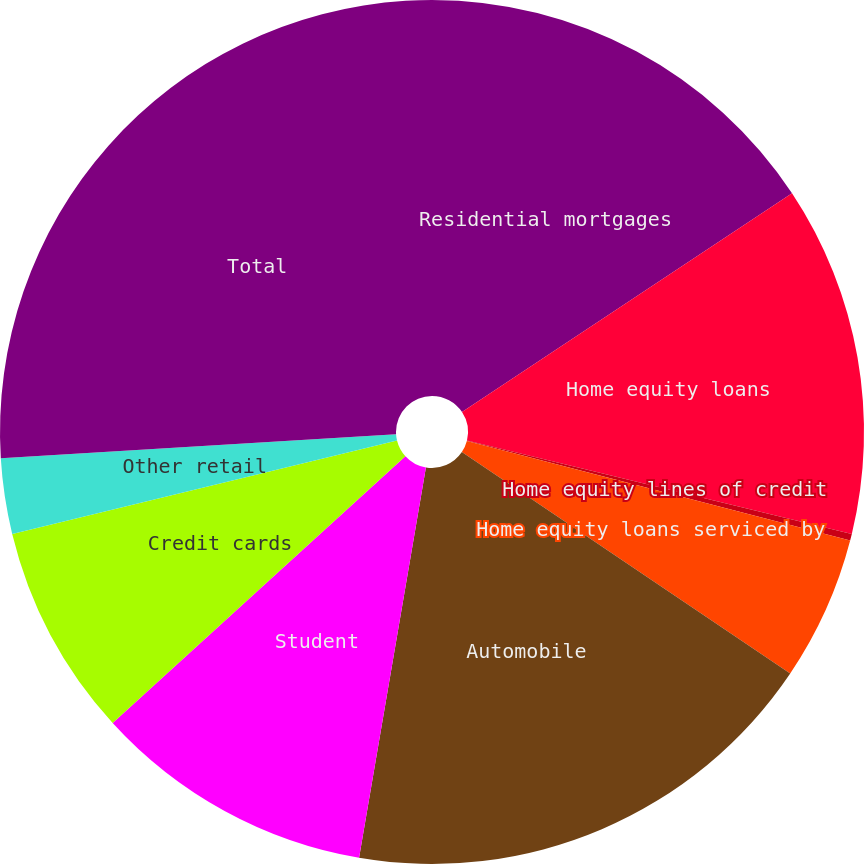Convert chart to OTSL. <chart><loc_0><loc_0><loc_500><loc_500><pie_chart><fcel>Residential mortgages<fcel>Home equity loans<fcel>Home equity lines of credit<fcel>Home equity loans serviced by<fcel>Automobile<fcel>Student<fcel>Credit cards<fcel>Other retail<fcel>Total<nl><fcel>15.68%<fcel>13.11%<fcel>0.25%<fcel>5.4%<fcel>18.26%<fcel>10.54%<fcel>7.97%<fcel>2.82%<fcel>25.97%<nl></chart> 